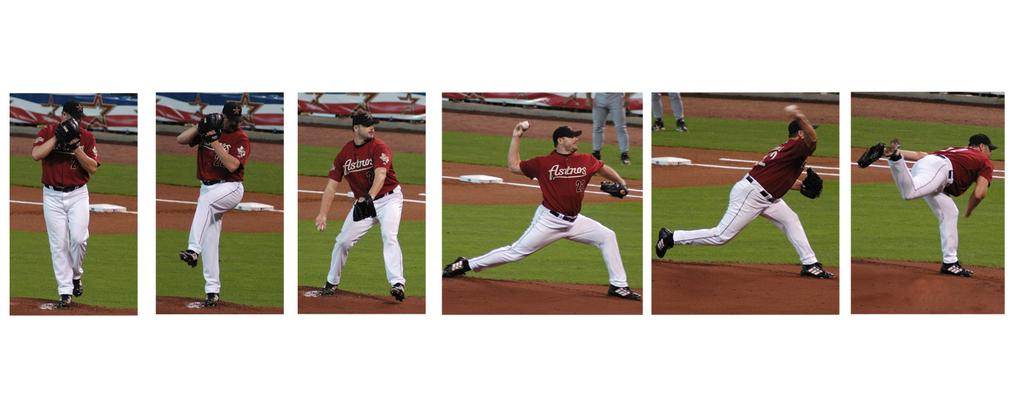<image>
Provide a brief description of the given image. a multi-framed photo of a baseball player pitching the ball with the Astro's 